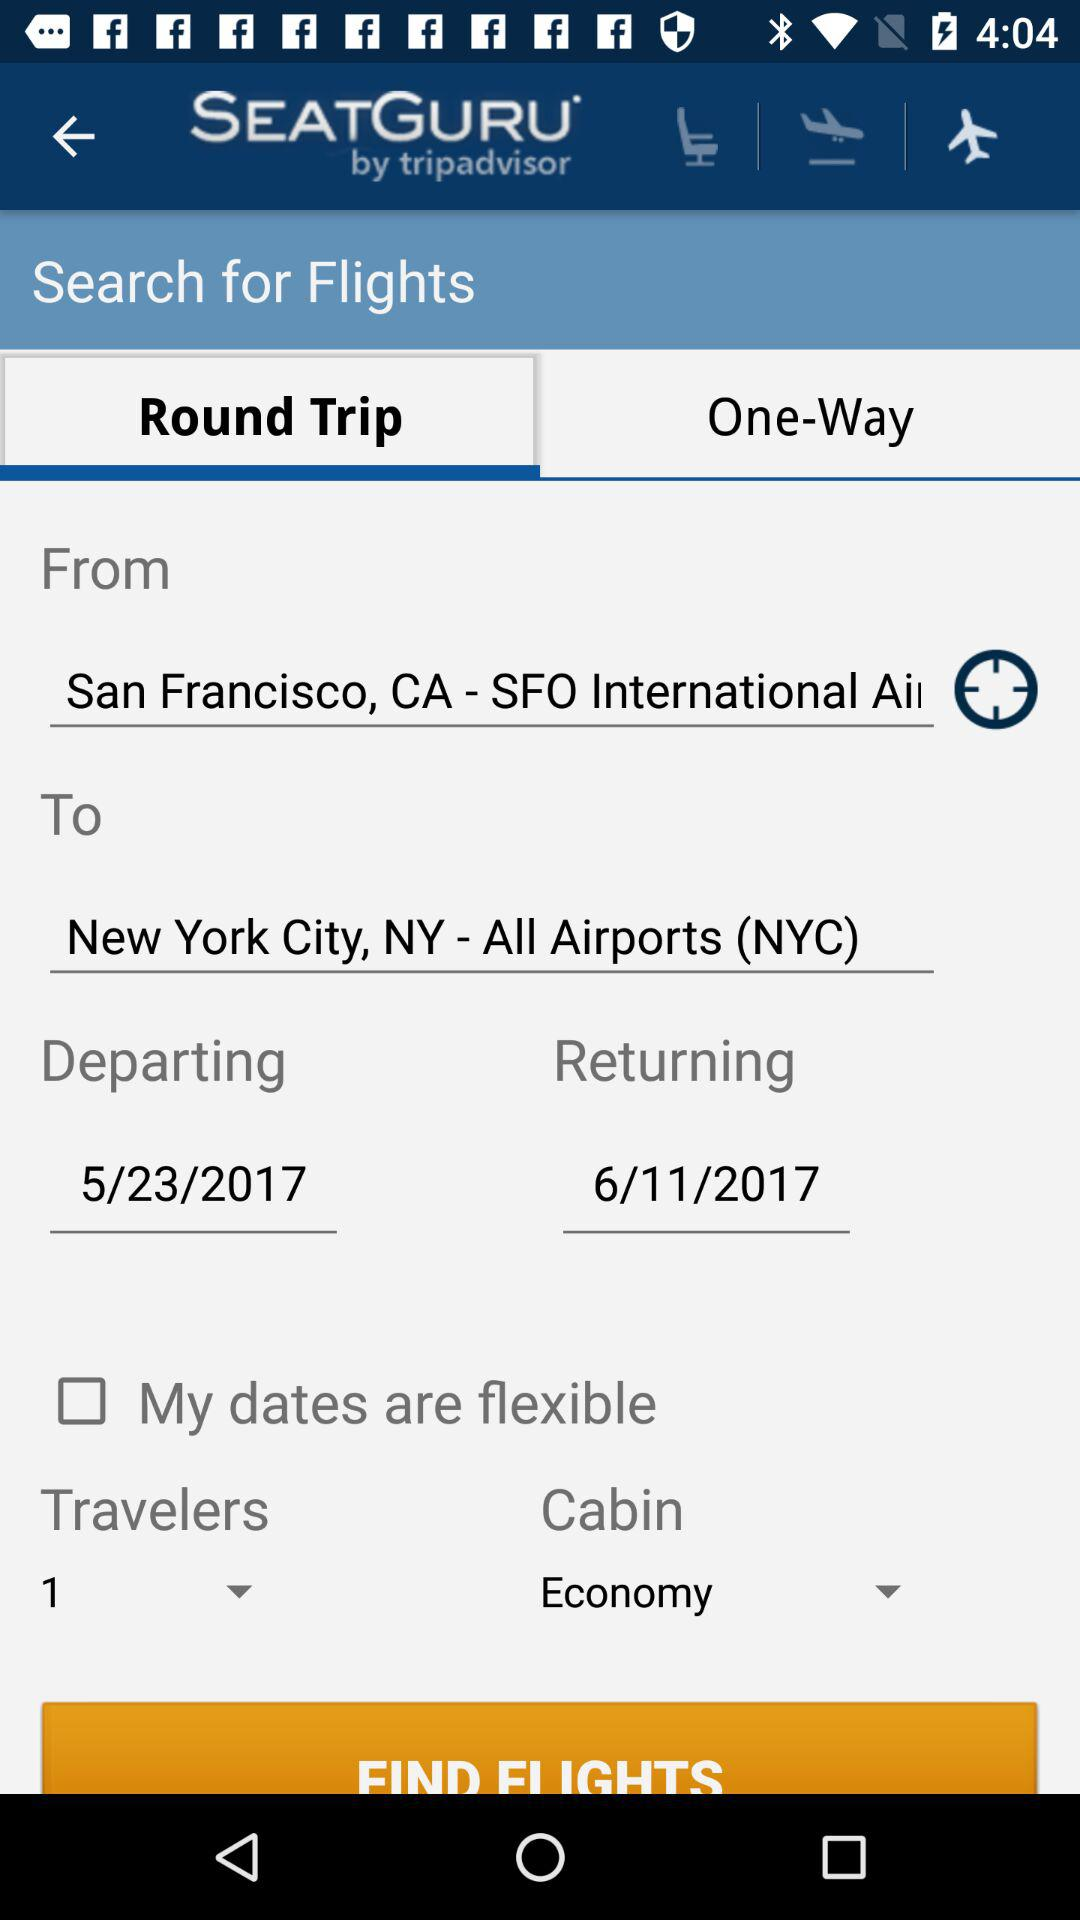How many people are flying?
Answer the question using a single word or phrase. 1 